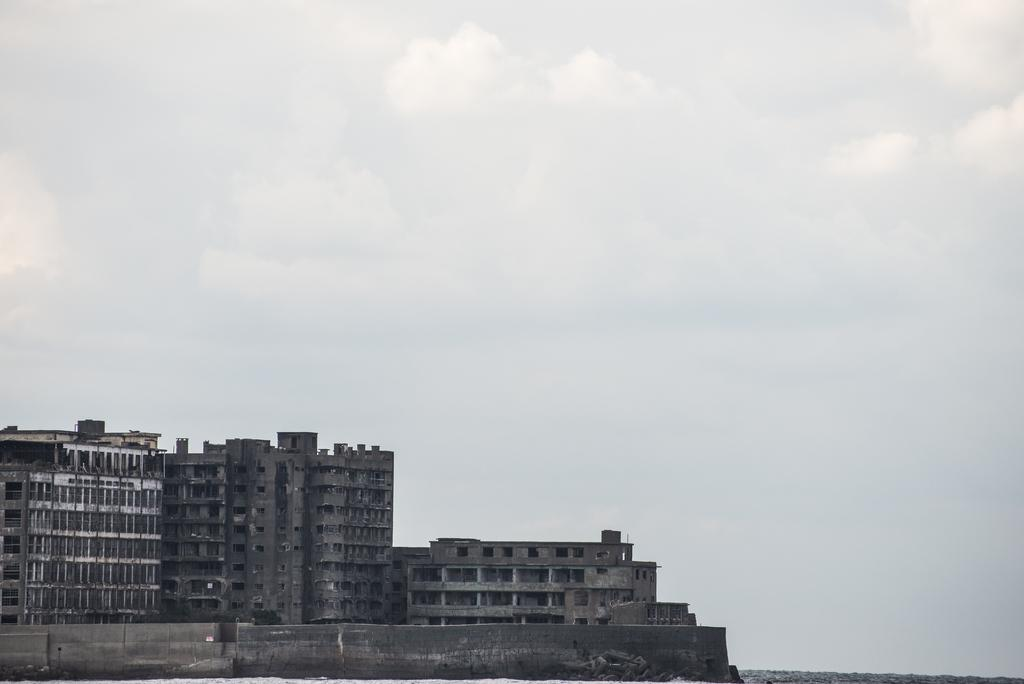What structures are located on the left side of the image? There are buildings on the left side of the image. What can be seen in the sky in the background of the image? There are clouds visible in the sky in the background of the image. Are there any fairies visible in the image? There are no fairies present in the image. What type of lunch is being served in the image? There is no lunch depicted in the image. 